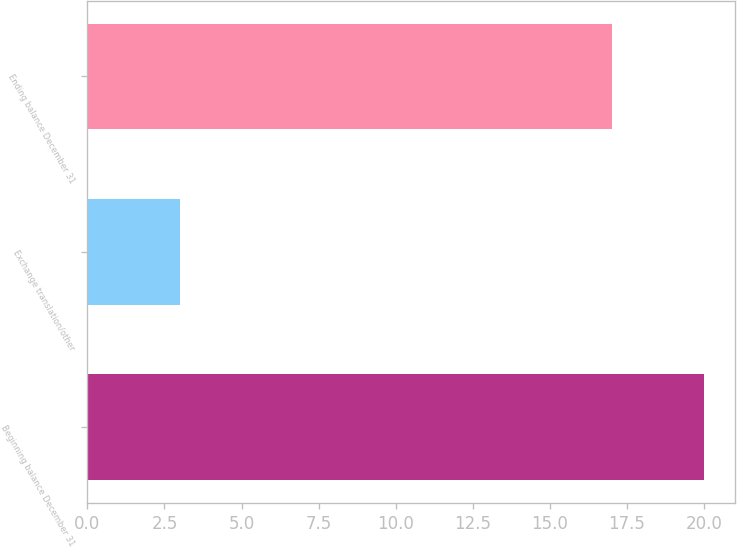<chart> <loc_0><loc_0><loc_500><loc_500><bar_chart><fcel>Beginning balance December 31<fcel>Exchange translation/other<fcel>Ending balance December 31<nl><fcel>20<fcel>3<fcel>17<nl></chart> 